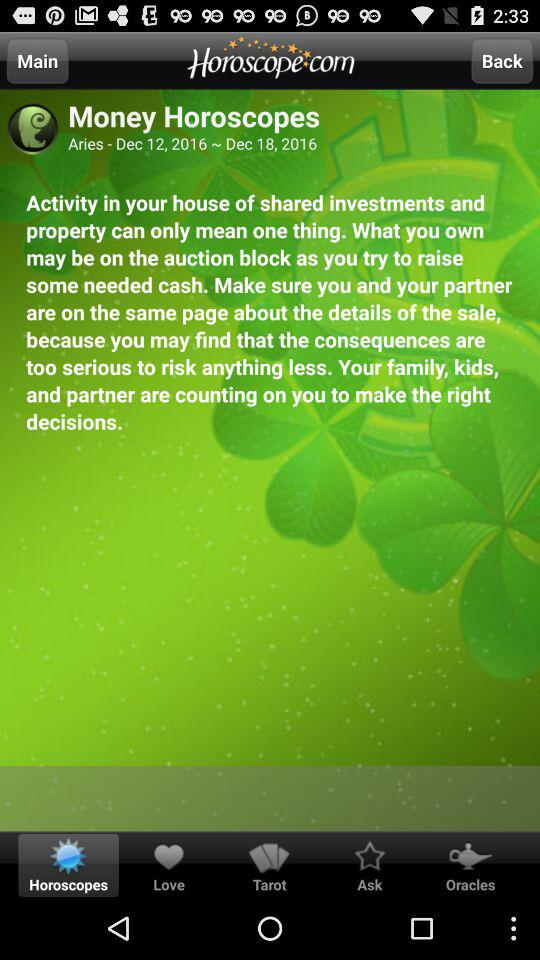Which tab has been selected? The selected tab is "Horoscopes". 